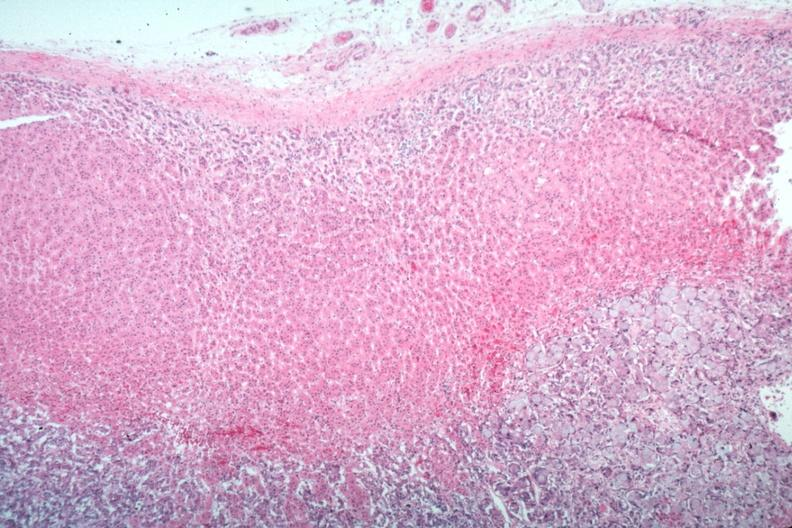s cortical nodule present?
Answer the question using a single word or phrase. No 